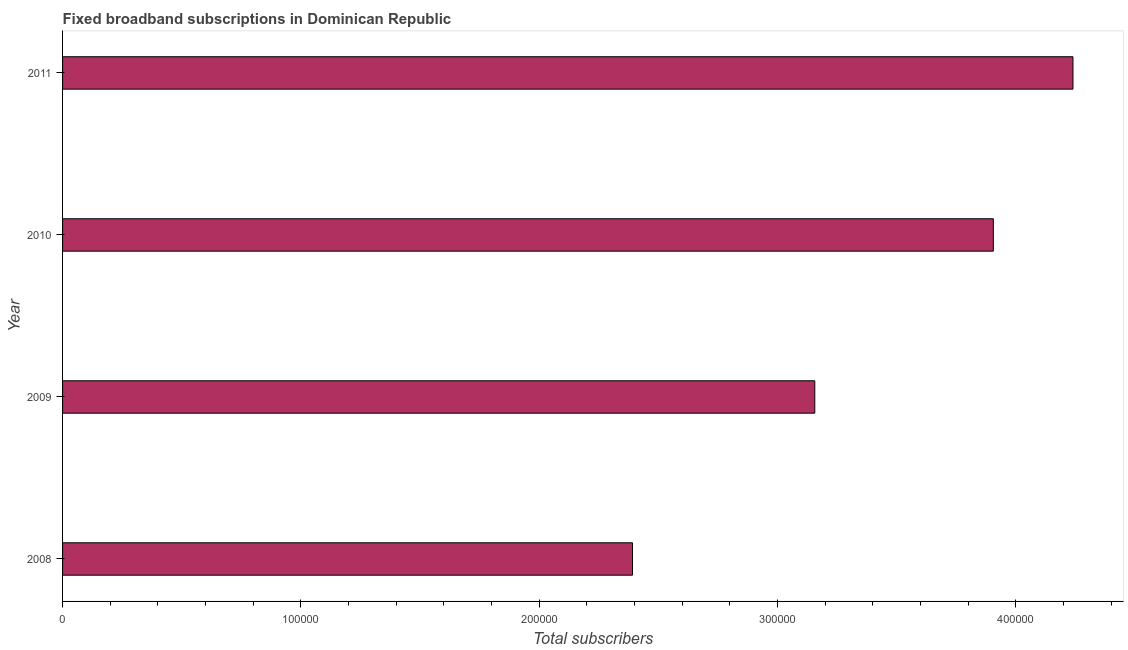Does the graph contain any zero values?
Your answer should be very brief. No. What is the title of the graph?
Your response must be concise. Fixed broadband subscriptions in Dominican Republic. What is the label or title of the X-axis?
Keep it short and to the point. Total subscribers. What is the label or title of the Y-axis?
Offer a terse response. Year. What is the total number of fixed broadband subscriptions in 2010?
Keep it short and to the point. 3.91e+05. Across all years, what is the maximum total number of fixed broadband subscriptions?
Keep it short and to the point. 4.24e+05. Across all years, what is the minimum total number of fixed broadband subscriptions?
Ensure brevity in your answer.  2.39e+05. In which year was the total number of fixed broadband subscriptions minimum?
Keep it short and to the point. 2008. What is the sum of the total number of fixed broadband subscriptions?
Keep it short and to the point. 1.37e+06. What is the difference between the total number of fixed broadband subscriptions in 2009 and 2010?
Ensure brevity in your answer.  -7.49e+04. What is the average total number of fixed broadband subscriptions per year?
Make the answer very short. 3.42e+05. What is the median total number of fixed broadband subscriptions?
Provide a succinct answer. 3.53e+05. In how many years, is the total number of fixed broadband subscriptions greater than 40000 ?
Offer a terse response. 4. What is the ratio of the total number of fixed broadband subscriptions in 2008 to that in 2011?
Your response must be concise. 0.56. Is the total number of fixed broadband subscriptions in 2008 less than that in 2010?
Your answer should be compact. Yes. What is the difference between the highest and the second highest total number of fixed broadband subscriptions?
Provide a short and direct response. 3.34e+04. What is the difference between the highest and the lowest total number of fixed broadband subscriptions?
Give a very brief answer. 1.85e+05. In how many years, is the total number of fixed broadband subscriptions greater than the average total number of fixed broadband subscriptions taken over all years?
Keep it short and to the point. 2. How many bars are there?
Make the answer very short. 4. How many years are there in the graph?
Make the answer very short. 4. What is the difference between two consecutive major ticks on the X-axis?
Give a very brief answer. 1.00e+05. Are the values on the major ticks of X-axis written in scientific E-notation?
Provide a succinct answer. No. What is the Total subscribers of 2008?
Your response must be concise. 2.39e+05. What is the Total subscribers of 2009?
Your answer should be compact. 3.16e+05. What is the Total subscribers of 2010?
Your response must be concise. 3.91e+05. What is the Total subscribers of 2011?
Keep it short and to the point. 4.24e+05. What is the difference between the Total subscribers in 2008 and 2009?
Your response must be concise. -7.65e+04. What is the difference between the Total subscribers in 2008 and 2010?
Give a very brief answer. -1.51e+05. What is the difference between the Total subscribers in 2008 and 2011?
Provide a short and direct response. -1.85e+05. What is the difference between the Total subscribers in 2009 and 2010?
Provide a succinct answer. -7.49e+04. What is the difference between the Total subscribers in 2009 and 2011?
Make the answer very short. -1.08e+05. What is the difference between the Total subscribers in 2010 and 2011?
Offer a terse response. -3.34e+04. What is the ratio of the Total subscribers in 2008 to that in 2009?
Ensure brevity in your answer.  0.76. What is the ratio of the Total subscribers in 2008 to that in 2010?
Your answer should be compact. 0.61. What is the ratio of the Total subscribers in 2008 to that in 2011?
Your answer should be very brief. 0.56. What is the ratio of the Total subscribers in 2009 to that in 2010?
Provide a succinct answer. 0.81. What is the ratio of the Total subscribers in 2009 to that in 2011?
Your answer should be compact. 0.74. What is the ratio of the Total subscribers in 2010 to that in 2011?
Offer a terse response. 0.92. 